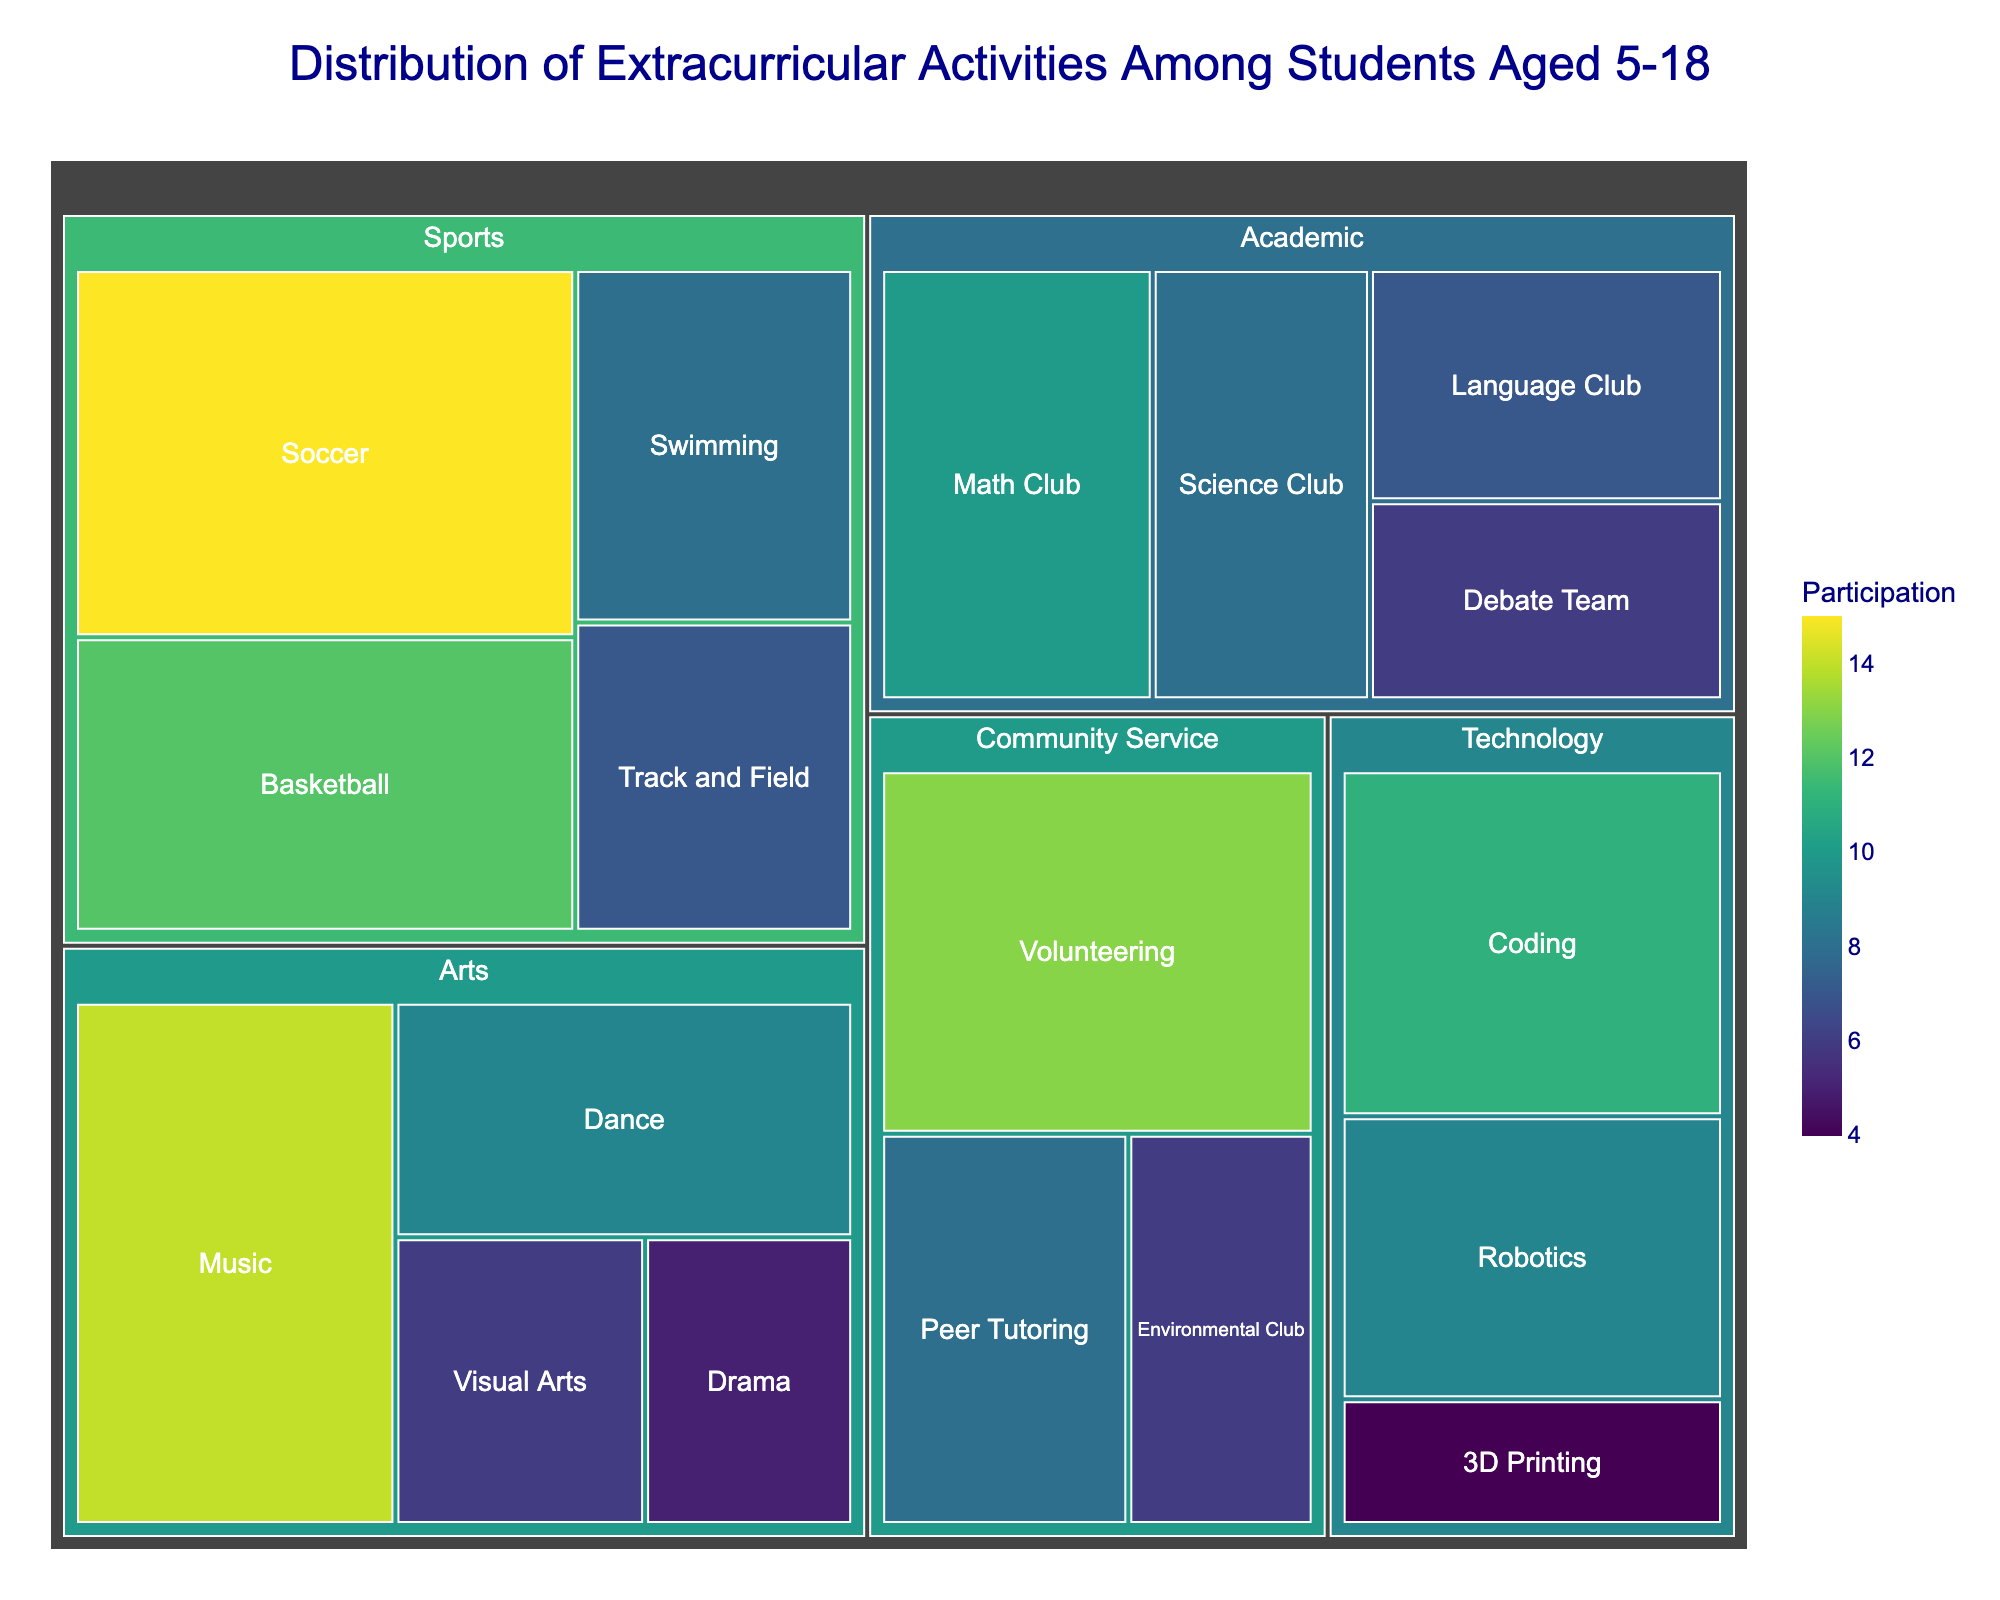What is the title of the treemap? The title of the treemap is prominently displayed at the top of the visualization.
Answer: Distribution of Extracurricular Activities Among Students Aged 5-18 Which subcategory has the highest participation in the Technology category? Look within the Technology category to find the subcategory with the largest area, which corresponds to the highest participation. The Coding subcategory has the highest participation with 11 participants.
Answer: Coding How many students participate in Artistic activities in total? To find the total number of students in the Arts category, sum the participation values of all the subcategories under Arts: Music (14), Dance (9), Visual Arts (6), Drama (5). So, the total is 14 + 9 + 6 + 5 = 34.
Answer: 34 Which category includes the subcategory of Peer Tutoring, and how many students participate in it? Locate the Peer Tutoring subcategory in the treemap, then identify its parent category. The Peer Tutoring subcategory lists 8 participants and belongs to the Community Service category.
Answer: Community Service, 8 Is the participation in Basketball higher than in Math Club? Compare the participation values directly from the treemap: Basketball has 12 participants and Math Club has 10 participants.
Answer: Yes What is the smallest participation number among all the categories? Identify the subcategory with the smallest area (value) in the treemap. The smallest participation number is found in the Technology category under 3D Printing, which has 4 participants.
Answer: 4 Which subcategory in Sports has the least participation and how many students are in it? Within the Sports category, identify the subcategory with the smallest area. Track and Field has the least participation with 7 students.
Answer: Track and Field, 7 What is the combined participation of students in all Community Service activities? Sum the participation numbers for all subcategories under Community Service: Volunteering (13), Environmental Club (6), Peer Tutoring (8). The total is 13 + 6 + 8 = 27.
Answer: 27 How does the participation in Music compare to that in Robotics? Compare the participation values: Music has 14 participants while Robotics has 9 participants.
Answer: Music has higher participation Which has more participants: the category of Arts or the category of Technology? Sum the participants for each subcategory within Arts (Music: 14, Dance: 9, Visual Arts: 6, Drama: 5) and within Technology (Coding: 11, Robotics: 9, 3D Printing: 4). Arts total is 34; Technology total is 24.
Answer: Arts 